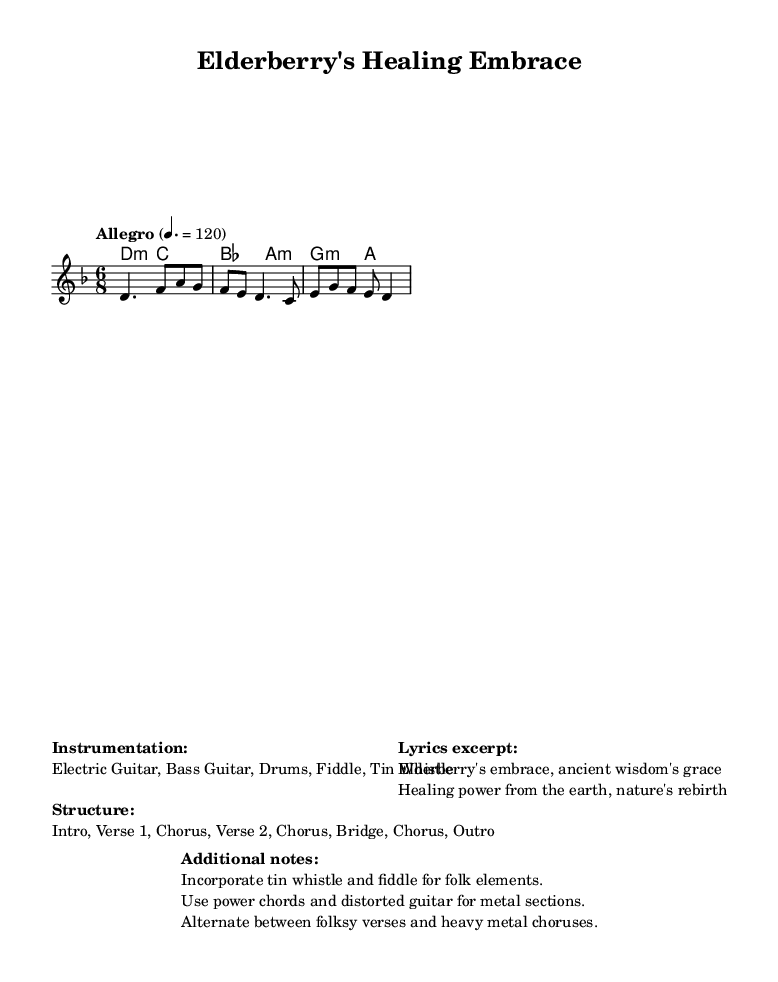What is the key signature of this music? The key signature is D minor, which is indicated by one flat (B flat) and is noted at the beginning of the score.
Answer: D minor What is the time signature of this piece? The time signature is 6/8, which shows that there are six eighth notes per measure, indicated at the beginning of the score.
Answer: 6/8 What is the tempo marking for this piece? The tempo marking is "Allegro" with a speed of 120 beats per minute, which means it should be played fast and lively.
Answer: Allegro 4. = 120 How many sections are in the song structure? The structure includes seven sections: Intro, Verse 1, Chorus, Verse 2, Chorus, Bridge, Chorus, Outro, as noted in the markup.
Answer: 7 Which instruments are used in this piece? The instrumentation includes Electric Guitar, Bass Guitar, Drums, Fiddle, and Tin Whistle, detailed in the markup.
Answer: Electric Guitar, Bass Guitar, Drums, Fiddle, Tin Whistle What is a notable feature of the song's arrangement? The arrangement alternates between folksy verses and heavy metal choruses, emphasizing the combination of folk elements and metal music.
Answer: Alternating verses and choruses 